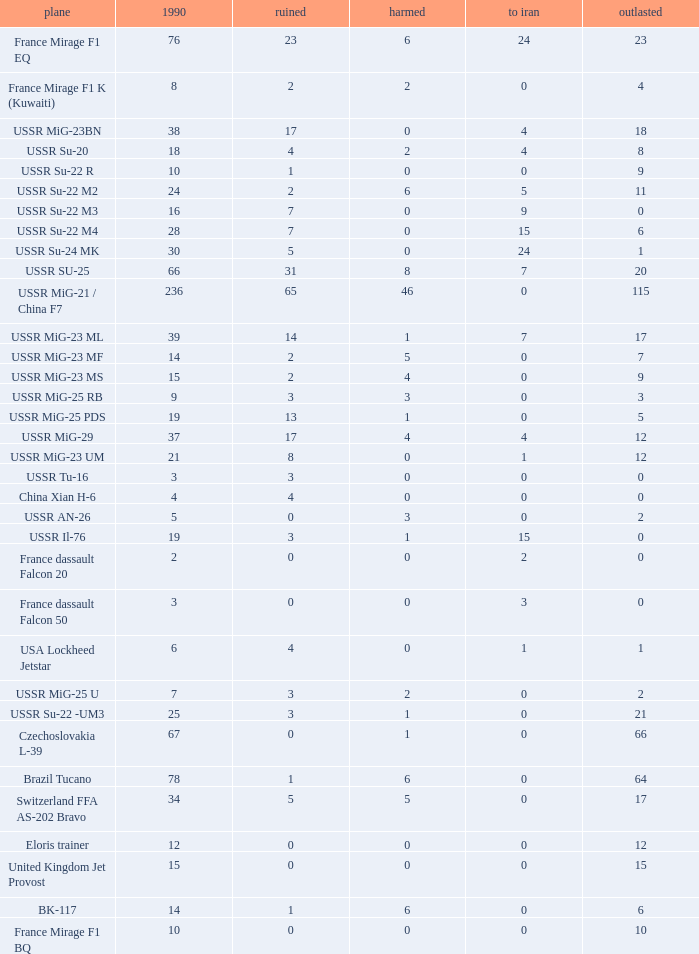If the aircraft was  ussr mig-25 rb how many were destroyed? 3.0. Could you parse the entire table as a dict? {'header': ['plane', '1990', 'ruined', 'harmed', 'to iran', 'outlasted'], 'rows': [['France Mirage F1 EQ', '76', '23', '6', '24', '23'], ['France Mirage F1 K (Kuwaiti)', '8', '2', '2', '0', '4'], ['USSR MiG-23BN', '38', '17', '0', '4', '18'], ['USSR Su-20', '18', '4', '2', '4', '8'], ['USSR Su-22 R', '10', '1', '0', '0', '9'], ['USSR Su-22 M2', '24', '2', '6', '5', '11'], ['USSR Su-22 M3', '16', '7', '0', '9', '0'], ['USSR Su-22 M4', '28', '7', '0', '15', '6'], ['USSR Su-24 MK', '30', '5', '0', '24', '1'], ['USSR SU-25', '66', '31', '8', '7', '20'], ['USSR MiG-21 / China F7', '236', '65', '46', '0', '115'], ['USSR MiG-23 ML', '39', '14', '1', '7', '17'], ['USSR MiG-23 MF', '14', '2', '5', '0', '7'], ['USSR MiG-23 MS', '15', '2', '4', '0', '9'], ['USSR MiG-25 RB', '9', '3', '3', '0', '3'], ['USSR MiG-25 PDS', '19', '13', '1', '0', '5'], ['USSR MiG-29', '37', '17', '4', '4', '12'], ['USSR MiG-23 UM', '21', '8', '0', '1', '12'], ['USSR Tu-16', '3', '3', '0', '0', '0'], ['China Xian H-6', '4', '4', '0', '0', '0'], ['USSR AN-26', '5', '0', '3', '0', '2'], ['USSR Il-76', '19', '3', '1', '15', '0'], ['France dassault Falcon 20', '2', '0', '0', '2', '0'], ['France dassault Falcon 50', '3', '0', '0', '3', '0'], ['USA Lockheed Jetstar', '6', '4', '0', '1', '1'], ['USSR MiG-25 U', '7', '3', '2', '0', '2'], ['USSR Su-22 -UM3', '25', '3', '1', '0', '21'], ['Czechoslovakia L-39', '67', '0', '1', '0', '66'], ['Brazil Tucano', '78', '1', '6', '0', '64'], ['Switzerland FFA AS-202 Bravo', '34', '5', '5', '0', '17'], ['Eloris trainer', '12', '0', '0', '0', '12'], ['United Kingdom Jet Provost', '15', '0', '0', '0', '15'], ['BK-117', '14', '1', '6', '0', '6'], ['France Mirage F1 BQ', '10', '0', '0', '0', '10']]} 